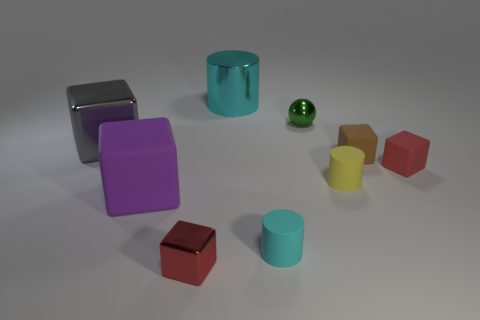Is the green metal object the same size as the metal cylinder?
Offer a terse response. No. There is a red block on the right side of the red cube in front of the tiny cyan matte thing; are there any metal cubes behind it?
Offer a very short reply. Yes. What is the material of the tiny brown object that is the same shape as the gray metal thing?
Make the answer very short. Rubber. How many tiny shiny objects are behind the cylinder to the right of the tiny metallic sphere?
Offer a terse response. 1. What is the size of the cyan thing on the left side of the small matte thing that is in front of the small cylinder to the right of the small green metallic ball?
Offer a very short reply. Large. There is a tiny shiny thing to the right of the tiny object left of the big cyan metallic cylinder; what is its color?
Keep it short and to the point. Green. How many other things are the same material as the tiny ball?
Your response must be concise. 3. How many other objects are there of the same color as the large metallic cylinder?
Offer a very short reply. 1. What is the red object that is behind the matte cylinder that is to the left of the green thing made of?
Provide a succinct answer. Rubber. Is there a small blue cylinder?
Give a very brief answer. No. 